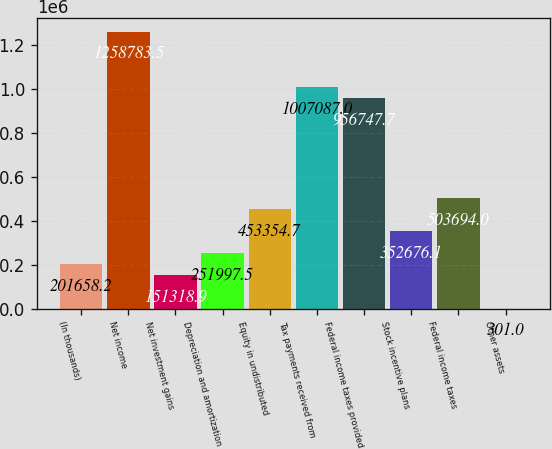<chart> <loc_0><loc_0><loc_500><loc_500><bar_chart><fcel>(In thousands)<fcel>Net income<fcel>Net investment gains<fcel>Depreciation and amortization<fcel>Equity in undistributed<fcel>Tax payments received from<fcel>Federal income taxes provided<fcel>Stock incentive plans<fcel>Federal income taxes<fcel>Other assets<nl><fcel>201658<fcel>1.25878e+06<fcel>151319<fcel>251998<fcel>453355<fcel>1.00709e+06<fcel>956748<fcel>352676<fcel>503694<fcel>301<nl></chart> 